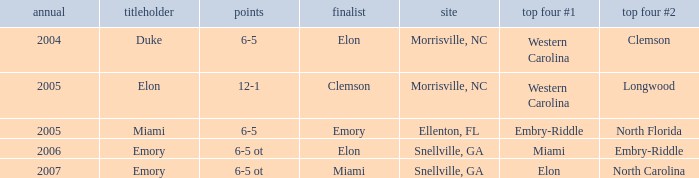List the scores of all games when Miami were listed as the first Semi finalist 6-5 ot. 